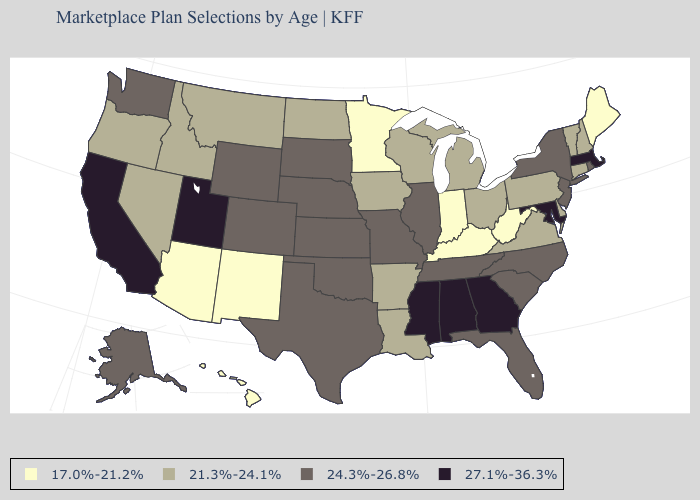Does Minnesota have the lowest value in the USA?
Write a very short answer. Yes. What is the value of Wyoming?
Concise answer only. 24.3%-26.8%. What is the highest value in the USA?
Write a very short answer. 27.1%-36.3%. Name the states that have a value in the range 27.1%-36.3%?
Give a very brief answer. Alabama, California, Georgia, Maryland, Massachusetts, Mississippi, Utah. Which states have the highest value in the USA?
Quick response, please. Alabama, California, Georgia, Maryland, Massachusetts, Mississippi, Utah. What is the value of Alaska?
Answer briefly. 24.3%-26.8%. What is the value of West Virginia?
Quick response, please. 17.0%-21.2%. What is the value of Nebraska?
Quick response, please. 24.3%-26.8%. What is the highest value in the MidWest ?
Quick response, please. 24.3%-26.8%. What is the value of Florida?
Be succinct. 24.3%-26.8%. Does Montana have a higher value than Georgia?
Answer briefly. No. Among the states that border Utah , which have the lowest value?
Answer briefly. Arizona, New Mexico. Name the states that have a value in the range 17.0%-21.2%?
Short answer required. Arizona, Hawaii, Indiana, Kentucky, Maine, Minnesota, New Mexico, West Virginia. What is the value of New York?
Short answer required. 24.3%-26.8%. Among the states that border New Mexico , which have the lowest value?
Be succinct. Arizona. 